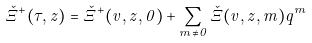Convert formula to latex. <formula><loc_0><loc_0><loc_500><loc_500>\check { \Xi } ^ { + } ( \tau , z ) = \check { \Xi } ^ { + } ( v , z , 0 ) + \sum _ { m \neq 0 } \check { \Xi } ( v , z , m ) q ^ { m }</formula> 